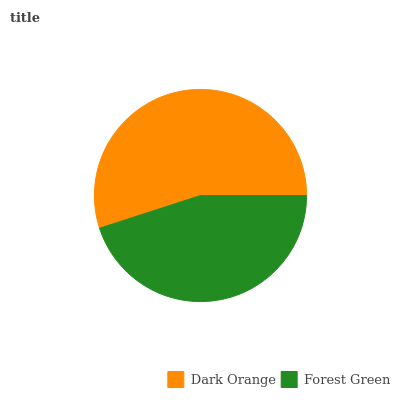Is Forest Green the minimum?
Answer yes or no. Yes. Is Dark Orange the maximum?
Answer yes or no. Yes. Is Forest Green the maximum?
Answer yes or no. No. Is Dark Orange greater than Forest Green?
Answer yes or no. Yes. Is Forest Green less than Dark Orange?
Answer yes or no. Yes. Is Forest Green greater than Dark Orange?
Answer yes or no. No. Is Dark Orange less than Forest Green?
Answer yes or no. No. Is Dark Orange the high median?
Answer yes or no. Yes. Is Forest Green the low median?
Answer yes or no. Yes. Is Forest Green the high median?
Answer yes or no. No. Is Dark Orange the low median?
Answer yes or no. No. 